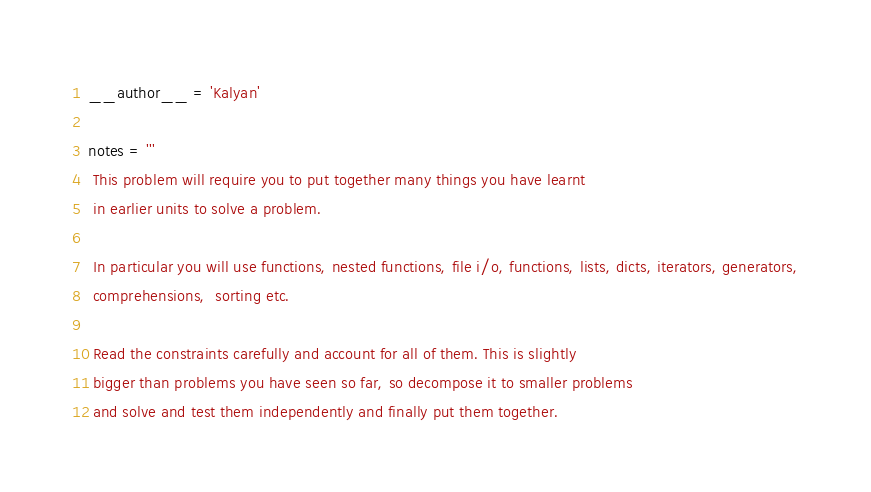<code> <loc_0><loc_0><loc_500><loc_500><_Python_>__author__ = 'Kalyan'

notes = '''
 This problem will require you to put together many things you have learnt
 in earlier units to solve a problem.

 In particular you will use functions, nested functions, file i/o, functions, lists, dicts, iterators, generators,
 comprehensions,  sorting etc.

 Read the constraints carefully and account for all of them. This is slightly
 bigger than problems you have seen so far, so decompose it to smaller problems
 and solve and test them independently and finally put them together.
</code> 